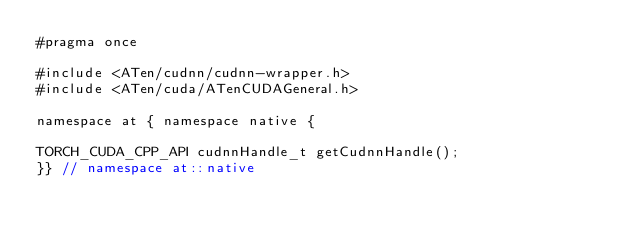Convert code to text. <code><loc_0><loc_0><loc_500><loc_500><_C_>#pragma once

#include <ATen/cudnn/cudnn-wrapper.h>
#include <ATen/cuda/ATenCUDAGeneral.h>

namespace at { namespace native {

TORCH_CUDA_CPP_API cudnnHandle_t getCudnnHandle();
}} // namespace at::native
</code> 